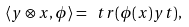<formula> <loc_0><loc_0><loc_500><loc_500>\langle y \otimes x , \phi \rangle = \ t r ( \phi ( x ) y ^ { \tt } t ) ,</formula> 